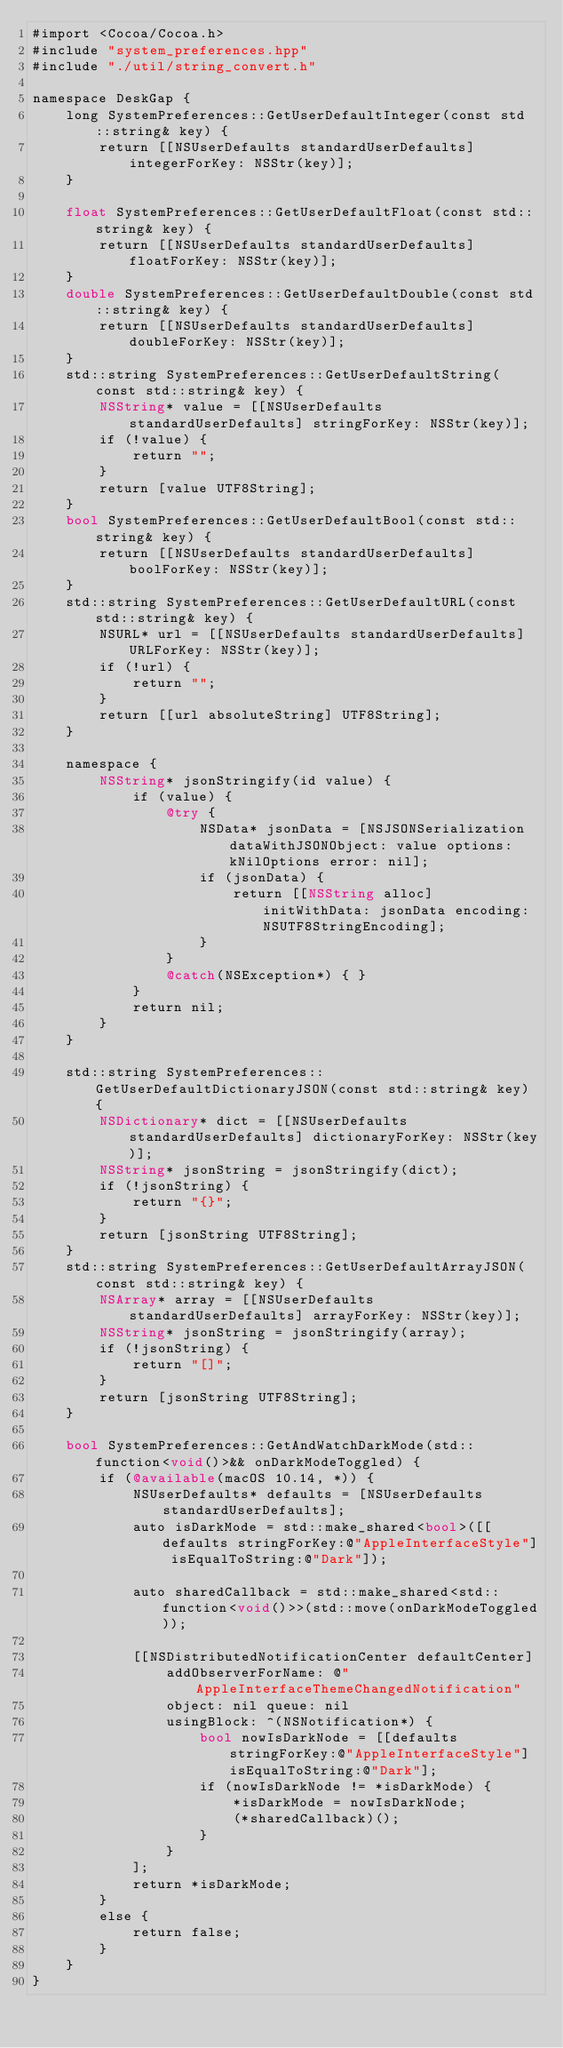<code> <loc_0><loc_0><loc_500><loc_500><_ObjectiveC_>#import <Cocoa/Cocoa.h>
#include "system_preferences.hpp"
#include "./util/string_convert.h"

namespace DeskGap {
    long SystemPreferences::GetUserDefaultInteger(const std::string& key) {
        return [[NSUserDefaults standardUserDefaults] integerForKey: NSStr(key)];
    }

    float SystemPreferences::GetUserDefaultFloat(const std::string& key) {
        return [[NSUserDefaults standardUserDefaults] floatForKey: NSStr(key)];
    }
    double SystemPreferences::GetUserDefaultDouble(const std::string& key) {
        return [[NSUserDefaults standardUserDefaults] doubleForKey: NSStr(key)];
    }
    std::string SystemPreferences::GetUserDefaultString(const std::string& key) {
        NSString* value = [[NSUserDefaults standardUserDefaults] stringForKey: NSStr(key)];
        if (!value) {
            return "";
        }
        return [value UTF8String];
    }
    bool SystemPreferences::GetUserDefaultBool(const std::string& key) {
        return [[NSUserDefaults standardUserDefaults] boolForKey: NSStr(key)];
    }
    std::string SystemPreferences::GetUserDefaultURL(const std::string& key) {
        NSURL* url = [[NSUserDefaults standardUserDefaults] URLForKey: NSStr(key)];
        if (!url) {
            return "";
        }
        return [[url absoluteString] UTF8String];
    }

    namespace {
        NSString* jsonStringify(id value) {
            if (value) {
                @try {
                    NSData* jsonData = [NSJSONSerialization dataWithJSONObject: value options: kNilOptions error: nil];
                    if (jsonData) {
                        return [[NSString alloc] initWithData: jsonData encoding: NSUTF8StringEncoding];
                    }
                }
                @catch(NSException*) { }
            }
            return nil;
        }
    }

    std::string SystemPreferences::GetUserDefaultDictionaryJSON(const std::string& key) {
        NSDictionary* dict = [[NSUserDefaults standardUserDefaults] dictionaryForKey: NSStr(key)];
        NSString* jsonString = jsonStringify(dict);
        if (!jsonString) {
            return "{}";
        }
        return [jsonString UTF8String];
    }
    std::string SystemPreferences::GetUserDefaultArrayJSON(const std::string& key) {
        NSArray* array = [[NSUserDefaults standardUserDefaults] arrayForKey: NSStr(key)];
        NSString* jsonString = jsonStringify(array);
        if (!jsonString) {
            return "[]";
        }
        return [jsonString UTF8String];
    }

    bool SystemPreferences::GetAndWatchDarkMode(std::function<void()>&& onDarkModeToggled) {
        if (@available(macOS 10.14, *)) {
            NSUserDefaults* defaults = [NSUserDefaults standardUserDefaults];
            auto isDarkMode = std::make_shared<bool>([[defaults stringForKey:@"AppleInterfaceStyle"] isEqualToString:@"Dark"]);

            auto sharedCallback = std::make_shared<std::function<void()>>(std::move(onDarkModeToggled));

            [[NSDistributedNotificationCenter defaultCenter]
                addObserverForName: @"AppleInterfaceThemeChangedNotification"
                object: nil queue: nil
                usingBlock: ^(NSNotification*) {
                    bool nowIsDarkNode = [[defaults stringForKey:@"AppleInterfaceStyle"] isEqualToString:@"Dark"];
                    if (nowIsDarkNode != *isDarkMode) {
                        *isDarkMode = nowIsDarkNode;
                        (*sharedCallback)();
                    }
                }
            ];
            return *isDarkMode;
        }
        else {
            return false;
        }
    }
}
</code> 